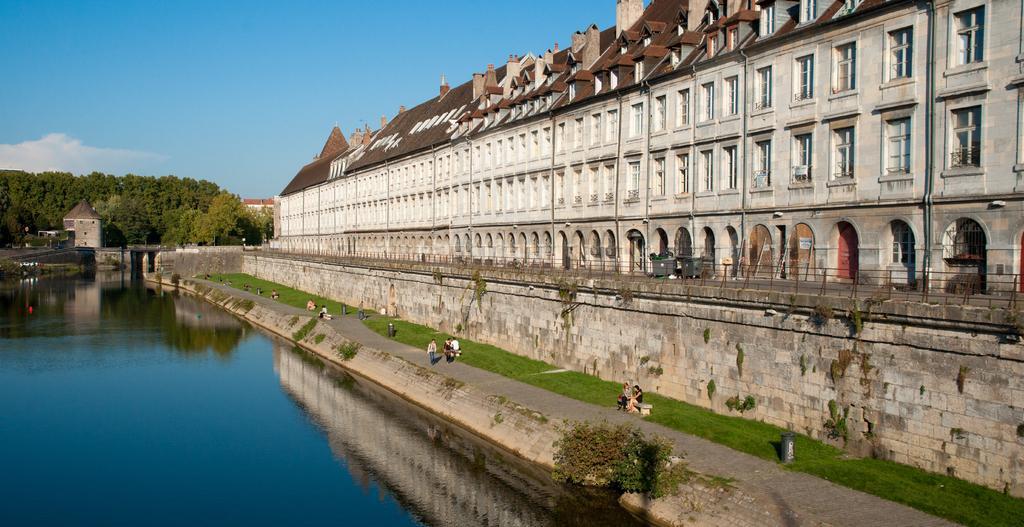Can you describe this image briefly? In this image there is the sky truncated towards the top of the image, there is a building truncated towards the right of the image, there is a wall truncated towards the right of the image, there are persons sitting on the benches, there is the grass, there are waste containers on the grass, there are trees truncated towards the left of the image, there is the water truncated towards the bottom of the image. 